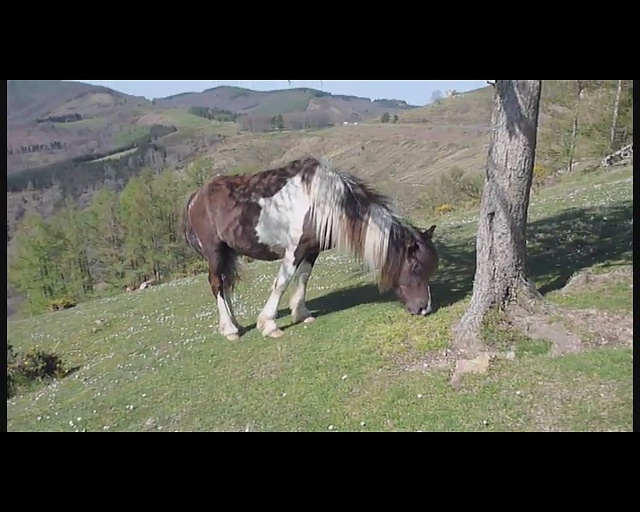Describe the objects in this image and their specific colors. I can see a horse in black, gray, darkgray, and lightgray tones in this image. 